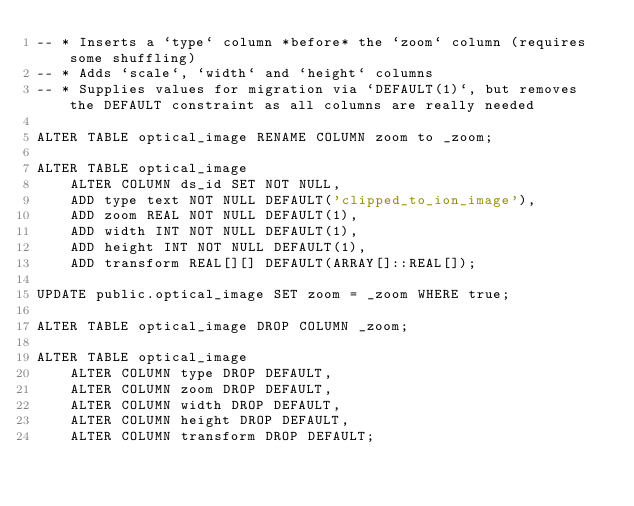Convert code to text. <code><loc_0><loc_0><loc_500><loc_500><_SQL_>-- * Inserts a `type` column *before* the `zoom` column (requires some shuffling)
-- * Adds `scale`, `width` and `height` columns
-- * Supplies values for migration via `DEFAULT(1)`, but removes the DEFAULT constraint as all columns are really needed

ALTER TABLE optical_image RENAME COLUMN zoom to _zoom;

ALTER TABLE optical_image
    ALTER COLUMN ds_id SET NOT NULL,
    ADD type text NOT NULL DEFAULT('clipped_to_ion_image'),
    ADD zoom REAL NOT NULL DEFAULT(1),
    ADD width INT NOT NULL DEFAULT(1),
    ADD height INT NOT NULL DEFAULT(1),
    ADD transform REAL[][] DEFAULT(ARRAY[]::REAL[]);

UPDATE public.optical_image SET zoom = _zoom WHERE true;

ALTER TABLE optical_image DROP COLUMN _zoom;

ALTER TABLE optical_image
    ALTER COLUMN type DROP DEFAULT,
    ALTER COLUMN zoom DROP DEFAULT,
    ALTER COLUMN width DROP DEFAULT,
    ALTER COLUMN height DROP DEFAULT,
    ALTER COLUMN transform DROP DEFAULT;</code> 